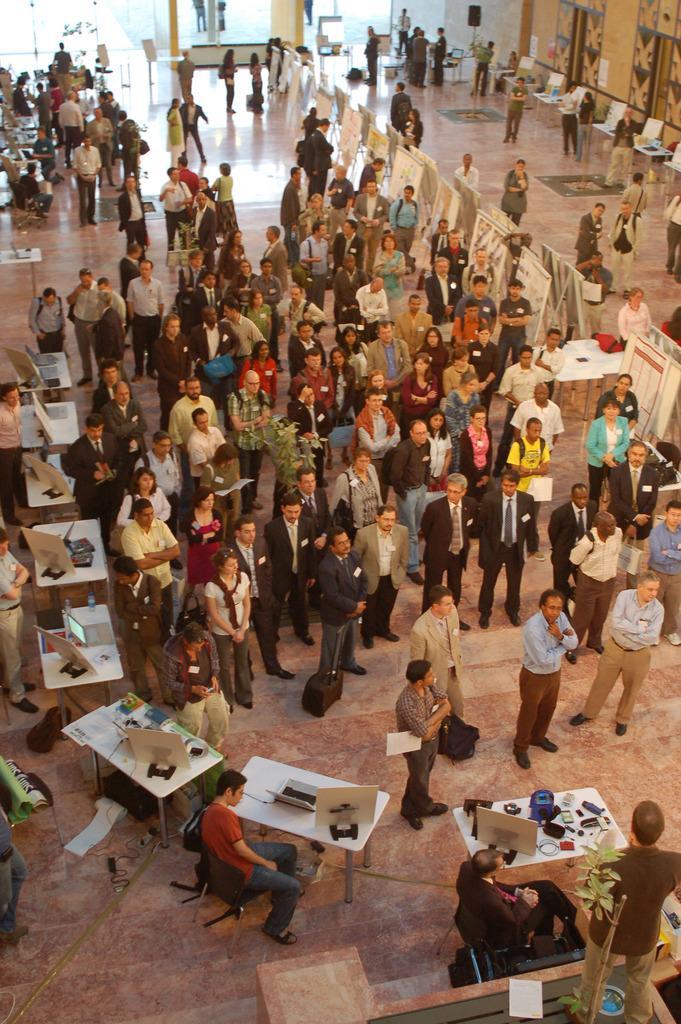In one or two sentences, can you explain what this image depicts? Some people gathered at a fair in a hall. 